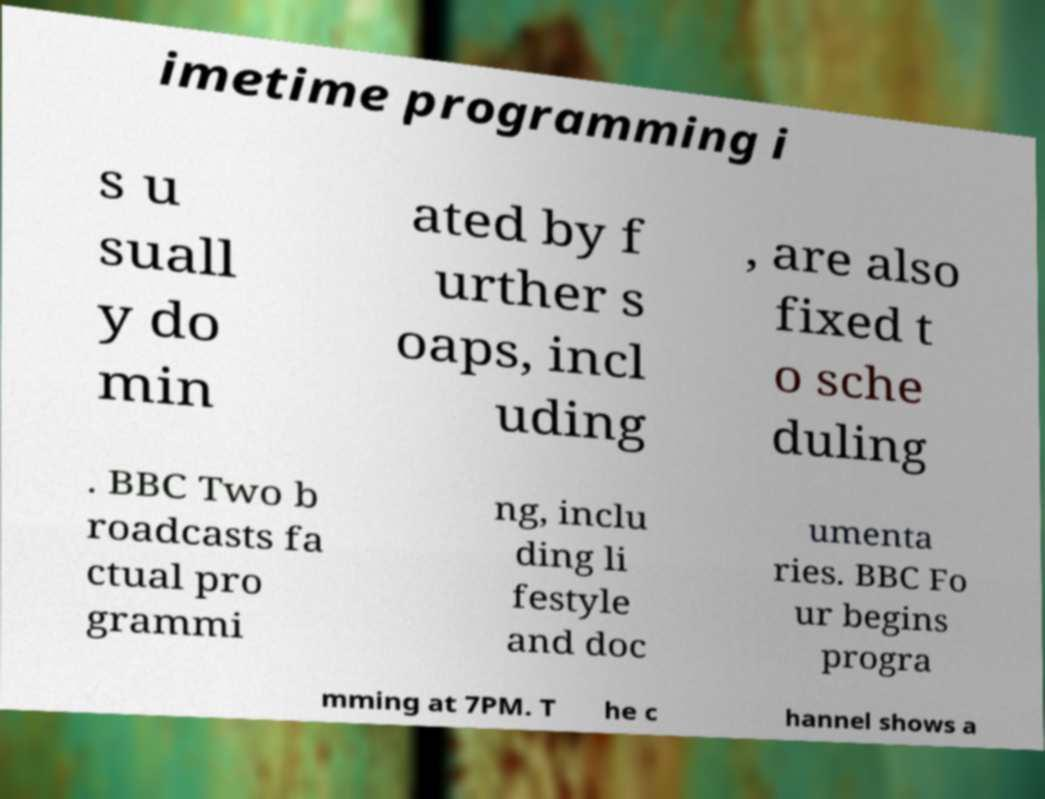Could you extract and type out the text from this image? imetime programming i s u suall y do min ated by f urther s oaps, incl uding , are also fixed t o sche duling . BBC Two b roadcasts fa ctual pro grammi ng, inclu ding li festyle and doc umenta ries. BBC Fo ur begins progra mming at 7PM. T he c hannel shows a 